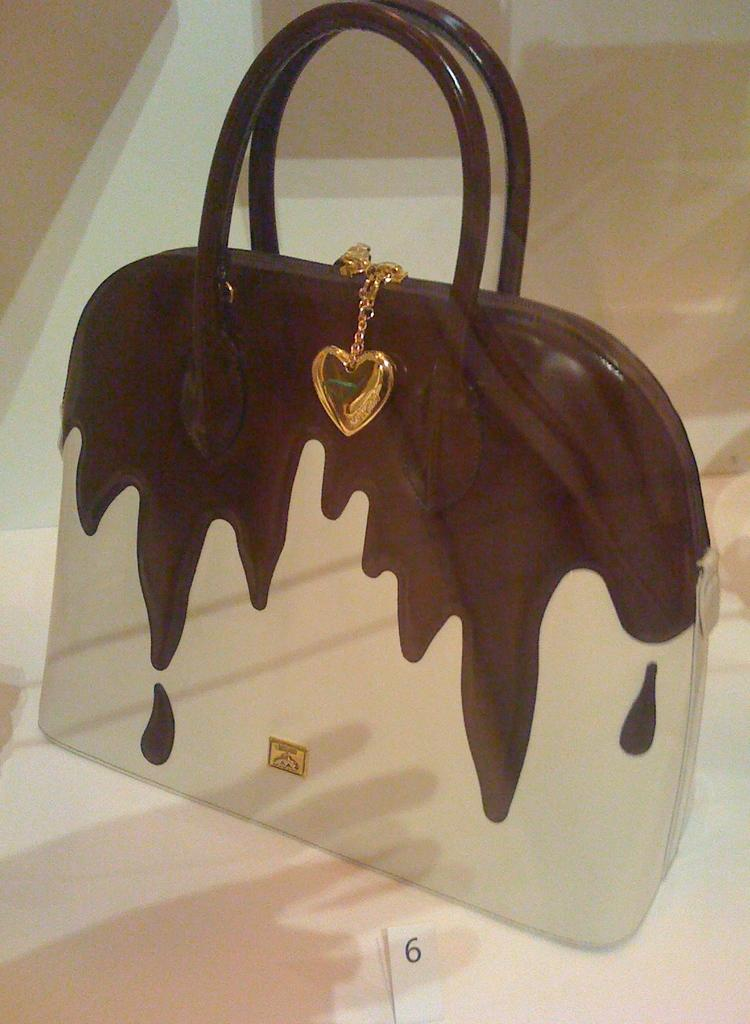What object can be seen on the floor in the image? There is a handbag in the image. Is there anything attached to the handbag? Yes, there is a locket attached to the handbag. Where are the handbag and locket located in the image? The handbag and locket are on the floor. What type of hen is depicted in the locket? There is no hen present in the image, as the locket is not shown in enough detail to depict any specific object or animal. 